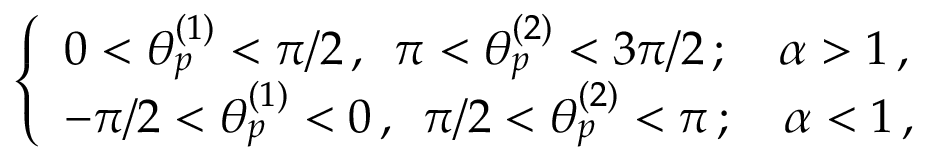Convert formula to latex. <formula><loc_0><loc_0><loc_500><loc_500>\begin{array} { r } { \left \{ \begin{array} { l l } { 0 < \theta _ { p } ^ { ( 1 ) } < \pi / 2 \, , \, \pi < \theta _ { p } ^ { ( 2 ) } < 3 \pi / 2 \, ; \quad \alpha > 1 \, , } \\ { - \pi / 2 < \theta _ { p } ^ { ( 1 ) } < 0 \, , \, \pi / 2 < \theta _ { p } ^ { ( 2 ) } < \pi \, ; \quad \alpha < 1 \, , } \end{array} } \end{array}</formula> 